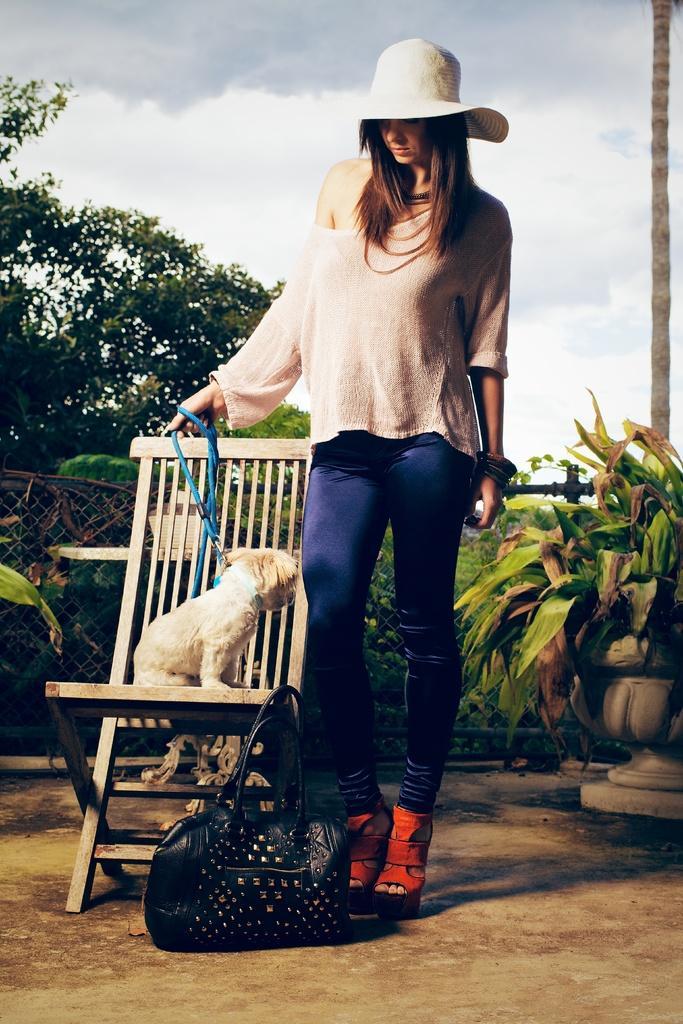In one or two sentences, can you explain what this image depicts? In this image I can see a woman wearing a hat, a cream color top and blue pant is standing holding a dog belt in her hand. I can see a bag on the floor and the chair on which there is a dog. In the background I can see few trees and the sky. 